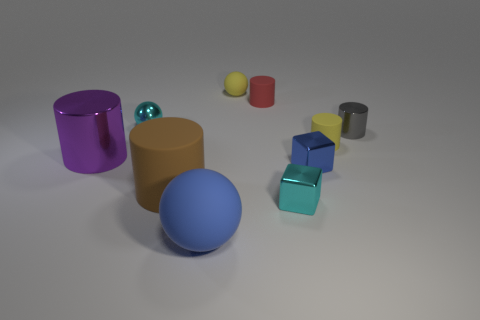Subtract 2 cylinders. How many cylinders are left? 3 Subtract all gray cylinders. How many cylinders are left? 4 Subtract all tiny red matte cylinders. How many cylinders are left? 4 Subtract all red cylinders. Subtract all purple balls. How many cylinders are left? 4 Subtract all cubes. How many objects are left? 8 Subtract all purple metallic things. Subtract all tiny metal cylinders. How many objects are left? 8 Add 1 tiny blue cubes. How many tiny blue cubes are left? 2 Add 1 tiny gray cylinders. How many tiny gray cylinders exist? 2 Subtract 1 yellow spheres. How many objects are left? 9 